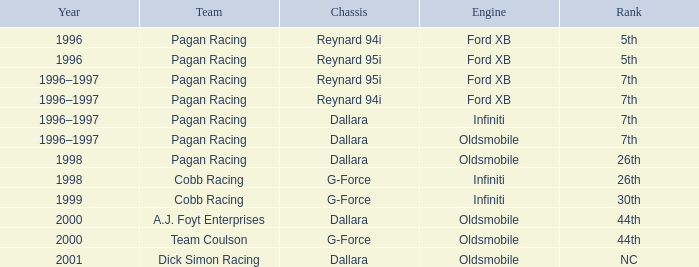What rank did the chassis reynard 94i have in 1996? 5th. 